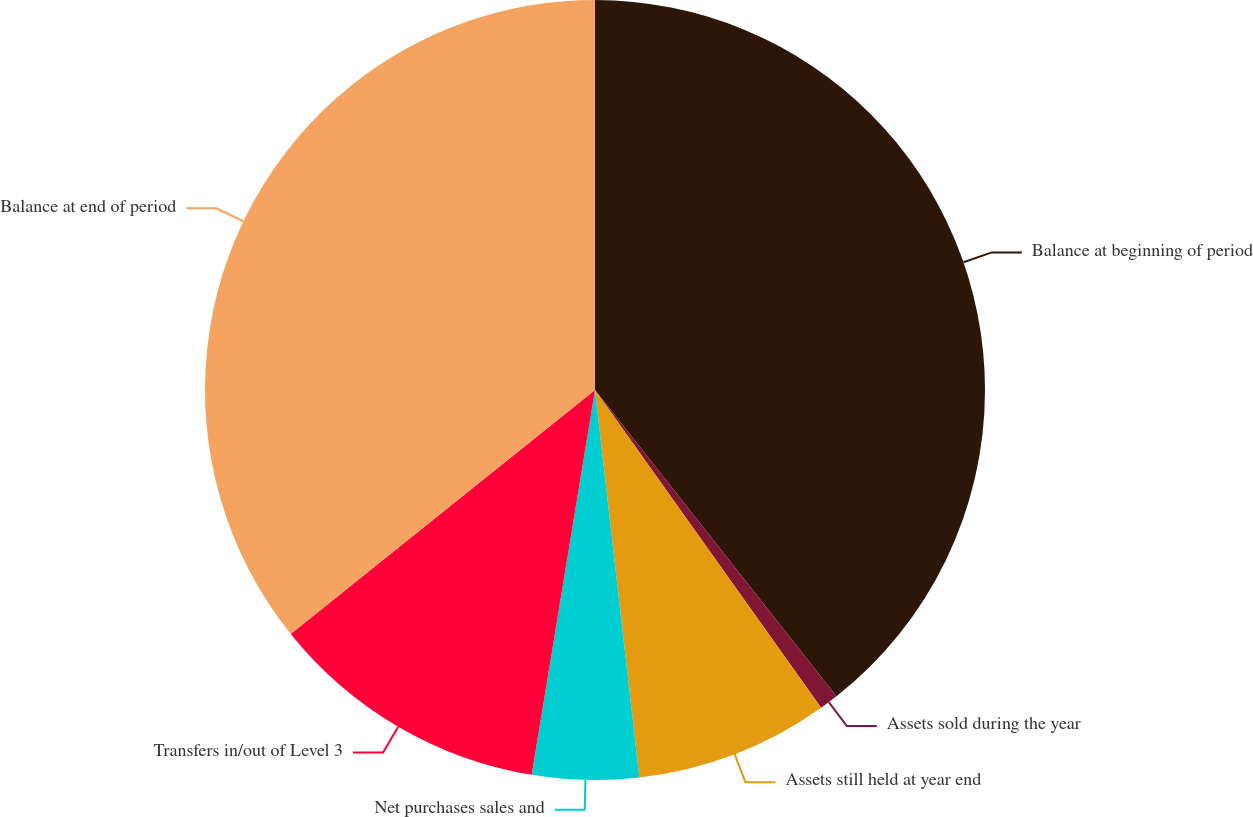Convert chart to OTSL. <chart><loc_0><loc_0><loc_500><loc_500><pie_chart><fcel>Balance at beginning of period<fcel>Assets sold during the year<fcel>Assets still held at year end<fcel>Net purchases sales and<fcel>Transfers in/out of Level 3<fcel>Balance at end of period<nl><fcel>39.38%<fcel>0.78%<fcel>8.03%<fcel>4.41%<fcel>11.65%<fcel>35.76%<nl></chart> 